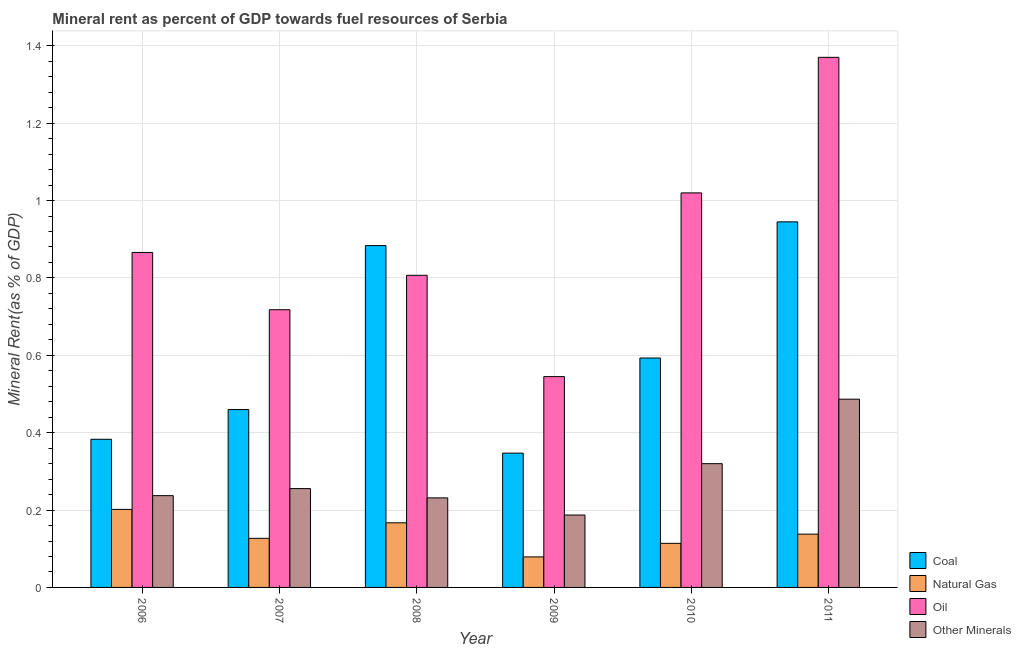How many different coloured bars are there?
Provide a short and direct response. 4. How many bars are there on the 2nd tick from the left?
Your answer should be very brief. 4. How many bars are there on the 1st tick from the right?
Ensure brevity in your answer.  4. What is the coal rent in 2008?
Provide a succinct answer. 0.88. Across all years, what is the maximum coal rent?
Keep it short and to the point. 0.94. Across all years, what is the minimum oil rent?
Provide a short and direct response. 0.54. In which year was the oil rent maximum?
Provide a short and direct response. 2011. In which year was the  rent of other minerals minimum?
Offer a very short reply. 2009. What is the total  rent of other minerals in the graph?
Make the answer very short. 1.72. What is the difference between the  rent of other minerals in 2006 and that in 2007?
Offer a terse response. -0.02. What is the difference between the  rent of other minerals in 2008 and the coal rent in 2006?
Offer a very short reply. -0.01. What is the average  rent of other minerals per year?
Provide a succinct answer. 0.29. What is the ratio of the coal rent in 2010 to that in 2011?
Keep it short and to the point. 0.63. What is the difference between the highest and the second highest natural gas rent?
Make the answer very short. 0.03. What is the difference between the highest and the lowest coal rent?
Make the answer very short. 0.6. In how many years, is the coal rent greater than the average coal rent taken over all years?
Give a very brief answer. 2. Is it the case that in every year, the sum of the coal rent and oil rent is greater than the sum of  rent of other minerals and natural gas rent?
Your answer should be very brief. No. What does the 1st bar from the left in 2006 represents?
Ensure brevity in your answer.  Coal. What does the 1st bar from the right in 2009 represents?
Keep it short and to the point. Other Minerals. How many bars are there?
Your answer should be compact. 24. Are all the bars in the graph horizontal?
Provide a succinct answer. No. Are the values on the major ticks of Y-axis written in scientific E-notation?
Your answer should be compact. No. How many legend labels are there?
Make the answer very short. 4. What is the title of the graph?
Make the answer very short. Mineral rent as percent of GDP towards fuel resources of Serbia. Does "Environmental sustainability" appear as one of the legend labels in the graph?
Offer a very short reply. No. What is the label or title of the Y-axis?
Keep it short and to the point. Mineral Rent(as % of GDP). What is the Mineral Rent(as % of GDP) of Coal in 2006?
Keep it short and to the point. 0.38. What is the Mineral Rent(as % of GDP) in Natural Gas in 2006?
Provide a succinct answer. 0.2. What is the Mineral Rent(as % of GDP) of Oil in 2006?
Keep it short and to the point. 0.87. What is the Mineral Rent(as % of GDP) in Other Minerals in 2006?
Your answer should be compact. 0.24. What is the Mineral Rent(as % of GDP) in Coal in 2007?
Provide a short and direct response. 0.46. What is the Mineral Rent(as % of GDP) of Natural Gas in 2007?
Offer a terse response. 0.13. What is the Mineral Rent(as % of GDP) of Oil in 2007?
Make the answer very short. 0.72. What is the Mineral Rent(as % of GDP) in Other Minerals in 2007?
Your answer should be very brief. 0.26. What is the Mineral Rent(as % of GDP) of Coal in 2008?
Provide a succinct answer. 0.88. What is the Mineral Rent(as % of GDP) of Natural Gas in 2008?
Give a very brief answer. 0.17. What is the Mineral Rent(as % of GDP) in Oil in 2008?
Your response must be concise. 0.81. What is the Mineral Rent(as % of GDP) of Other Minerals in 2008?
Provide a short and direct response. 0.23. What is the Mineral Rent(as % of GDP) of Coal in 2009?
Make the answer very short. 0.35. What is the Mineral Rent(as % of GDP) in Natural Gas in 2009?
Give a very brief answer. 0.08. What is the Mineral Rent(as % of GDP) of Oil in 2009?
Provide a succinct answer. 0.54. What is the Mineral Rent(as % of GDP) in Other Minerals in 2009?
Ensure brevity in your answer.  0.19. What is the Mineral Rent(as % of GDP) in Coal in 2010?
Your response must be concise. 0.59. What is the Mineral Rent(as % of GDP) of Natural Gas in 2010?
Ensure brevity in your answer.  0.11. What is the Mineral Rent(as % of GDP) of Oil in 2010?
Give a very brief answer. 1.02. What is the Mineral Rent(as % of GDP) in Other Minerals in 2010?
Give a very brief answer. 0.32. What is the Mineral Rent(as % of GDP) in Coal in 2011?
Provide a short and direct response. 0.94. What is the Mineral Rent(as % of GDP) of Natural Gas in 2011?
Give a very brief answer. 0.14. What is the Mineral Rent(as % of GDP) in Oil in 2011?
Your response must be concise. 1.37. What is the Mineral Rent(as % of GDP) of Other Minerals in 2011?
Your answer should be very brief. 0.49. Across all years, what is the maximum Mineral Rent(as % of GDP) in Coal?
Make the answer very short. 0.94. Across all years, what is the maximum Mineral Rent(as % of GDP) in Natural Gas?
Keep it short and to the point. 0.2. Across all years, what is the maximum Mineral Rent(as % of GDP) of Oil?
Your response must be concise. 1.37. Across all years, what is the maximum Mineral Rent(as % of GDP) of Other Minerals?
Provide a succinct answer. 0.49. Across all years, what is the minimum Mineral Rent(as % of GDP) in Coal?
Provide a short and direct response. 0.35. Across all years, what is the minimum Mineral Rent(as % of GDP) of Natural Gas?
Give a very brief answer. 0.08. Across all years, what is the minimum Mineral Rent(as % of GDP) in Oil?
Your answer should be compact. 0.54. Across all years, what is the minimum Mineral Rent(as % of GDP) in Other Minerals?
Your answer should be very brief. 0.19. What is the total Mineral Rent(as % of GDP) in Coal in the graph?
Offer a terse response. 3.61. What is the total Mineral Rent(as % of GDP) in Natural Gas in the graph?
Your answer should be compact. 0.83. What is the total Mineral Rent(as % of GDP) of Oil in the graph?
Provide a short and direct response. 5.33. What is the total Mineral Rent(as % of GDP) in Other Minerals in the graph?
Keep it short and to the point. 1.72. What is the difference between the Mineral Rent(as % of GDP) in Coal in 2006 and that in 2007?
Your answer should be very brief. -0.08. What is the difference between the Mineral Rent(as % of GDP) of Natural Gas in 2006 and that in 2007?
Make the answer very short. 0.07. What is the difference between the Mineral Rent(as % of GDP) in Oil in 2006 and that in 2007?
Offer a terse response. 0.15. What is the difference between the Mineral Rent(as % of GDP) of Other Minerals in 2006 and that in 2007?
Provide a succinct answer. -0.02. What is the difference between the Mineral Rent(as % of GDP) in Coal in 2006 and that in 2008?
Offer a very short reply. -0.5. What is the difference between the Mineral Rent(as % of GDP) in Natural Gas in 2006 and that in 2008?
Provide a short and direct response. 0.03. What is the difference between the Mineral Rent(as % of GDP) in Oil in 2006 and that in 2008?
Keep it short and to the point. 0.06. What is the difference between the Mineral Rent(as % of GDP) in Other Minerals in 2006 and that in 2008?
Offer a very short reply. 0.01. What is the difference between the Mineral Rent(as % of GDP) in Coal in 2006 and that in 2009?
Make the answer very short. 0.04. What is the difference between the Mineral Rent(as % of GDP) in Natural Gas in 2006 and that in 2009?
Offer a very short reply. 0.12. What is the difference between the Mineral Rent(as % of GDP) in Oil in 2006 and that in 2009?
Give a very brief answer. 0.32. What is the difference between the Mineral Rent(as % of GDP) in Other Minerals in 2006 and that in 2009?
Provide a short and direct response. 0.05. What is the difference between the Mineral Rent(as % of GDP) of Coal in 2006 and that in 2010?
Give a very brief answer. -0.21. What is the difference between the Mineral Rent(as % of GDP) of Natural Gas in 2006 and that in 2010?
Provide a succinct answer. 0.09. What is the difference between the Mineral Rent(as % of GDP) in Oil in 2006 and that in 2010?
Keep it short and to the point. -0.15. What is the difference between the Mineral Rent(as % of GDP) in Other Minerals in 2006 and that in 2010?
Make the answer very short. -0.08. What is the difference between the Mineral Rent(as % of GDP) in Coal in 2006 and that in 2011?
Provide a succinct answer. -0.56. What is the difference between the Mineral Rent(as % of GDP) in Natural Gas in 2006 and that in 2011?
Give a very brief answer. 0.06. What is the difference between the Mineral Rent(as % of GDP) in Oil in 2006 and that in 2011?
Provide a succinct answer. -0.5. What is the difference between the Mineral Rent(as % of GDP) of Other Minerals in 2006 and that in 2011?
Give a very brief answer. -0.25. What is the difference between the Mineral Rent(as % of GDP) of Coal in 2007 and that in 2008?
Make the answer very short. -0.42. What is the difference between the Mineral Rent(as % of GDP) in Natural Gas in 2007 and that in 2008?
Your answer should be compact. -0.04. What is the difference between the Mineral Rent(as % of GDP) in Oil in 2007 and that in 2008?
Ensure brevity in your answer.  -0.09. What is the difference between the Mineral Rent(as % of GDP) of Other Minerals in 2007 and that in 2008?
Give a very brief answer. 0.02. What is the difference between the Mineral Rent(as % of GDP) of Coal in 2007 and that in 2009?
Your answer should be very brief. 0.11. What is the difference between the Mineral Rent(as % of GDP) in Natural Gas in 2007 and that in 2009?
Provide a succinct answer. 0.05. What is the difference between the Mineral Rent(as % of GDP) of Oil in 2007 and that in 2009?
Ensure brevity in your answer.  0.17. What is the difference between the Mineral Rent(as % of GDP) in Other Minerals in 2007 and that in 2009?
Your response must be concise. 0.07. What is the difference between the Mineral Rent(as % of GDP) in Coal in 2007 and that in 2010?
Ensure brevity in your answer.  -0.13. What is the difference between the Mineral Rent(as % of GDP) of Natural Gas in 2007 and that in 2010?
Provide a short and direct response. 0.01. What is the difference between the Mineral Rent(as % of GDP) in Oil in 2007 and that in 2010?
Provide a short and direct response. -0.3. What is the difference between the Mineral Rent(as % of GDP) in Other Minerals in 2007 and that in 2010?
Your response must be concise. -0.06. What is the difference between the Mineral Rent(as % of GDP) of Coal in 2007 and that in 2011?
Keep it short and to the point. -0.49. What is the difference between the Mineral Rent(as % of GDP) of Natural Gas in 2007 and that in 2011?
Your response must be concise. -0.01. What is the difference between the Mineral Rent(as % of GDP) of Oil in 2007 and that in 2011?
Give a very brief answer. -0.65. What is the difference between the Mineral Rent(as % of GDP) of Other Minerals in 2007 and that in 2011?
Your answer should be compact. -0.23. What is the difference between the Mineral Rent(as % of GDP) of Coal in 2008 and that in 2009?
Offer a very short reply. 0.54. What is the difference between the Mineral Rent(as % of GDP) of Natural Gas in 2008 and that in 2009?
Keep it short and to the point. 0.09. What is the difference between the Mineral Rent(as % of GDP) of Oil in 2008 and that in 2009?
Offer a very short reply. 0.26. What is the difference between the Mineral Rent(as % of GDP) in Other Minerals in 2008 and that in 2009?
Offer a terse response. 0.04. What is the difference between the Mineral Rent(as % of GDP) of Coal in 2008 and that in 2010?
Provide a short and direct response. 0.29. What is the difference between the Mineral Rent(as % of GDP) in Natural Gas in 2008 and that in 2010?
Offer a very short reply. 0.05. What is the difference between the Mineral Rent(as % of GDP) in Oil in 2008 and that in 2010?
Provide a short and direct response. -0.21. What is the difference between the Mineral Rent(as % of GDP) in Other Minerals in 2008 and that in 2010?
Provide a short and direct response. -0.09. What is the difference between the Mineral Rent(as % of GDP) in Coal in 2008 and that in 2011?
Keep it short and to the point. -0.06. What is the difference between the Mineral Rent(as % of GDP) of Natural Gas in 2008 and that in 2011?
Your answer should be very brief. 0.03. What is the difference between the Mineral Rent(as % of GDP) of Oil in 2008 and that in 2011?
Keep it short and to the point. -0.56. What is the difference between the Mineral Rent(as % of GDP) in Other Minerals in 2008 and that in 2011?
Your answer should be compact. -0.26. What is the difference between the Mineral Rent(as % of GDP) of Coal in 2009 and that in 2010?
Your response must be concise. -0.25. What is the difference between the Mineral Rent(as % of GDP) of Natural Gas in 2009 and that in 2010?
Your answer should be very brief. -0.04. What is the difference between the Mineral Rent(as % of GDP) in Oil in 2009 and that in 2010?
Offer a very short reply. -0.47. What is the difference between the Mineral Rent(as % of GDP) in Other Minerals in 2009 and that in 2010?
Offer a very short reply. -0.13. What is the difference between the Mineral Rent(as % of GDP) in Coal in 2009 and that in 2011?
Keep it short and to the point. -0.6. What is the difference between the Mineral Rent(as % of GDP) in Natural Gas in 2009 and that in 2011?
Ensure brevity in your answer.  -0.06. What is the difference between the Mineral Rent(as % of GDP) in Oil in 2009 and that in 2011?
Provide a succinct answer. -0.83. What is the difference between the Mineral Rent(as % of GDP) in Other Minerals in 2009 and that in 2011?
Make the answer very short. -0.3. What is the difference between the Mineral Rent(as % of GDP) of Coal in 2010 and that in 2011?
Offer a terse response. -0.35. What is the difference between the Mineral Rent(as % of GDP) in Natural Gas in 2010 and that in 2011?
Ensure brevity in your answer.  -0.02. What is the difference between the Mineral Rent(as % of GDP) of Oil in 2010 and that in 2011?
Provide a short and direct response. -0.35. What is the difference between the Mineral Rent(as % of GDP) of Other Minerals in 2010 and that in 2011?
Provide a short and direct response. -0.17. What is the difference between the Mineral Rent(as % of GDP) in Coal in 2006 and the Mineral Rent(as % of GDP) in Natural Gas in 2007?
Give a very brief answer. 0.26. What is the difference between the Mineral Rent(as % of GDP) in Coal in 2006 and the Mineral Rent(as % of GDP) in Oil in 2007?
Provide a short and direct response. -0.33. What is the difference between the Mineral Rent(as % of GDP) of Coal in 2006 and the Mineral Rent(as % of GDP) of Other Minerals in 2007?
Keep it short and to the point. 0.13. What is the difference between the Mineral Rent(as % of GDP) in Natural Gas in 2006 and the Mineral Rent(as % of GDP) in Oil in 2007?
Provide a short and direct response. -0.52. What is the difference between the Mineral Rent(as % of GDP) of Natural Gas in 2006 and the Mineral Rent(as % of GDP) of Other Minerals in 2007?
Provide a short and direct response. -0.05. What is the difference between the Mineral Rent(as % of GDP) of Oil in 2006 and the Mineral Rent(as % of GDP) of Other Minerals in 2007?
Offer a very short reply. 0.61. What is the difference between the Mineral Rent(as % of GDP) in Coal in 2006 and the Mineral Rent(as % of GDP) in Natural Gas in 2008?
Make the answer very short. 0.22. What is the difference between the Mineral Rent(as % of GDP) of Coal in 2006 and the Mineral Rent(as % of GDP) of Oil in 2008?
Your answer should be compact. -0.42. What is the difference between the Mineral Rent(as % of GDP) in Coal in 2006 and the Mineral Rent(as % of GDP) in Other Minerals in 2008?
Keep it short and to the point. 0.15. What is the difference between the Mineral Rent(as % of GDP) in Natural Gas in 2006 and the Mineral Rent(as % of GDP) in Oil in 2008?
Make the answer very short. -0.61. What is the difference between the Mineral Rent(as % of GDP) of Natural Gas in 2006 and the Mineral Rent(as % of GDP) of Other Minerals in 2008?
Your answer should be very brief. -0.03. What is the difference between the Mineral Rent(as % of GDP) of Oil in 2006 and the Mineral Rent(as % of GDP) of Other Minerals in 2008?
Your response must be concise. 0.63. What is the difference between the Mineral Rent(as % of GDP) in Coal in 2006 and the Mineral Rent(as % of GDP) in Natural Gas in 2009?
Offer a very short reply. 0.3. What is the difference between the Mineral Rent(as % of GDP) of Coal in 2006 and the Mineral Rent(as % of GDP) of Oil in 2009?
Offer a terse response. -0.16. What is the difference between the Mineral Rent(as % of GDP) of Coal in 2006 and the Mineral Rent(as % of GDP) of Other Minerals in 2009?
Your response must be concise. 0.2. What is the difference between the Mineral Rent(as % of GDP) of Natural Gas in 2006 and the Mineral Rent(as % of GDP) of Oil in 2009?
Give a very brief answer. -0.34. What is the difference between the Mineral Rent(as % of GDP) in Natural Gas in 2006 and the Mineral Rent(as % of GDP) in Other Minerals in 2009?
Offer a very short reply. 0.01. What is the difference between the Mineral Rent(as % of GDP) in Oil in 2006 and the Mineral Rent(as % of GDP) in Other Minerals in 2009?
Offer a very short reply. 0.68. What is the difference between the Mineral Rent(as % of GDP) in Coal in 2006 and the Mineral Rent(as % of GDP) in Natural Gas in 2010?
Offer a very short reply. 0.27. What is the difference between the Mineral Rent(as % of GDP) in Coal in 2006 and the Mineral Rent(as % of GDP) in Oil in 2010?
Provide a succinct answer. -0.64. What is the difference between the Mineral Rent(as % of GDP) of Coal in 2006 and the Mineral Rent(as % of GDP) of Other Minerals in 2010?
Your answer should be very brief. 0.06. What is the difference between the Mineral Rent(as % of GDP) of Natural Gas in 2006 and the Mineral Rent(as % of GDP) of Oil in 2010?
Your answer should be very brief. -0.82. What is the difference between the Mineral Rent(as % of GDP) of Natural Gas in 2006 and the Mineral Rent(as % of GDP) of Other Minerals in 2010?
Ensure brevity in your answer.  -0.12. What is the difference between the Mineral Rent(as % of GDP) in Oil in 2006 and the Mineral Rent(as % of GDP) in Other Minerals in 2010?
Your response must be concise. 0.55. What is the difference between the Mineral Rent(as % of GDP) in Coal in 2006 and the Mineral Rent(as % of GDP) in Natural Gas in 2011?
Your answer should be compact. 0.25. What is the difference between the Mineral Rent(as % of GDP) in Coal in 2006 and the Mineral Rent(as % of GDP) in Oil in 2011?
Provide a short and direct response. -0.99. What is the difference between the Mineral Rent(as % of GDP) in Coal in 2006 and the Mineral Rent(as % of GDP) in Other Minerals in 2011?
Give a very brief answer. -0.1. What is the difference between the Mineral Rent(as % of GDP) in Natural Gas in 2006 and the Mineral Rent(as % of GDP) in Oil in 2011?
Provide a short and direct response. -1.17. What is the difference between the Mineral Rent(as % of GDP) of Natural Gas in 2006 and the Mineral Rent(as % of GDP) of Other Minerals in 2011?
Keep it short and to the point. -0.28. What is the difference between the Mineral Rent(as % of GDP) in Oil in 2006 and the Mineral Rent(as % of GDP) in Other Minerals in 2011?
Offer a terse response. 0.38. What is the difference between the Mineral Rent(as % of GDP) in Coal in 2007 and the Mineral Rent(as % of GDP) in Natural Gas in 2008?
Your answer should be compact. 0.29. What is the difference between the Mineral Rent(as % of GDP) of Coal in 2007 and the Mineral Rent(as % of GDP) of Oil in 2008?
Your answer should be compact. -0.35. What is the difference between the Mineral Rent(as % of GDP) of Coal in 2007 and the Mineral Rent(as % of GDP) of Other Minerals in 2008?
Offer a very short reply. 0.23. What is the difference between the Mineral Rent(as % of GDP) of Natural Gas in 2007 and the Mineral Rent(as % of GDP) of Oil in 2008?
Give a very brief answer. -0.68. What is the difference between the Mineral Rent(as % of GDP) of Natural Gas in 2007 and the Mineral Rent(as % of GDP) of Other Minerals in 2008?
Give a very brief answer. -0.1. What is the difference between the Mineral Rent(as % of GDP) of Oil in 2007 and the Mineral Rent(as % of GDP) of Other Minerals in 2008?
Ensure brevity in your answer.  0.49. What is the difference between the Mineral Rent(as % of GDP) of Coal in 2007 and the Mineral Rent(as % of GDP) of Natural Gas in 2009?
Give a very brief answer. 0.38. What is the difference between the Mineral Rent(as % of GDP) of Coal in 2007 and the Mineral Rent(as % of GDP) of Oil in 2009?
Your response must be concise. -0.09. What is the difference between the Mineral Rent(as % of GDP) in Coal in 2007 and the Mineral Rent(as % of GDP) in Other Minerals in 2009?
Give a very brief answer. 0.27. What is the difference between the Mineral Rent(as % of GDP) in Natural Gas in 2007 and the Mineral Rent(as % of GDP) in Oil in 2009?
Offer a very short reply. -0.42. What is the difference between the Mineral Rent(as % of GDP) of Natural Gas in 2007 and the Mineral Rent(as % of GDP) of Other Minerals in 2009?
Give a very brief answer. -0.06. What is the difference between the Mineral Rent(as % of GDP) in Oil in 2007 and the Mineral Rent(as % of GDP) in Other Minerals in 2009?
Offer a very short reply. 0.53. What is the difference between the Mineral Rent(as % of GDP) in Coal in 2007 and the Mineral Rent(as % of GDP) in Natural Gas in 2010?
Your response must be concise. 0.35. What is the difference between the Mineral Rent(as % of GDP) in Coal in 2007 and the Mineral Rent(as % of GDP) in Oil in 2010?
Give a very brief answer. -0.56. What is the difference between the Mineral Rent(as % of GDP) in Coal in 2007 and the Mineral Rent(as % of GDP) in Other Minerals in 2010?
Make the answer very short. 0.14. What is the difference between the Mineral Rent(as % of GDP) of Natural Gas in 2007 and the Mineral Rent(as % of GDP) of Oil in 2010?
Ensure brevity in your answer.  -0.89. What is the difference between the Mineral Rent(as % of GDP) of Natural Gas in 2007 and the Mineral Rent(as % of GDP) of Other Minerals in 2010?
Provide a succinct answer. -0.19. What is the difference between the Mineral Rent(as % of GDP) in Oil in 2007 and the Mineral Rent(as % of GDP) in Other Minerals in 2010?
Make the answer very short. 0.4. What is the difference between the Mineral Rent(as % of GDP) in Coal in 2007 and the Mineral Rent(as % of GDP) in Natural Gas in 2011?
Give a very brief answer. 0.32. What is the difference between the Mineral Rent(as % of GDP) of Coal in 2007 and the Mineral Rent(as % of GDP) of Oil in 2011?
Provide a succinct answer. -0.91. What is the difference between the Mineral Rent(as % of GDP) in Coal in 2007 and the Mineral Rent(as % of GDP) in Other Minerals in 2011?
Give a very brief answer. -0.03. What is the difference between the Mineral Rent(as % of GDP) in Natural Gas in 2007 and the Mineral Rent(as % of GDP) in Oil in 2011?
Ensure brevity in your answer.  -1.24. What is the difference between the Mineral Rent(as % of GDP) of Natural Gas in 2007 and the Mineral Rent(as % of GDP) of Other Minerals in 2011?
Offer a very short reply. -0.36. What is the difference between the Mineral Rent(as % of GDP) in Oil in 2007 and the Mineral Rent(as % of GDP) in Other Minerals in 2011?
Provide a short and direct response. 0.23. What is the difference between the Mineral Rent(as % of GDP) in Coal in 2008 and the Mineral Rent(as % of GDP) in Natural Gas in 2009?
Keep it short and to the point. 0.8. What is the difference between the Mineral Rent(as % of GDP) of Coal in 2008 and the Mineral Rent(as % of GDP) of Oil in 2009?
Ensure brevity in your answer.  0.34. What is the difference between the Mineral Rent(as % of GDP) in Coal in 2008 and the Mineral Rent(as % of GDP) in Other Minerals in 2009?
Provide a succinct answer. 0.7. What is the difference between the Mineral Rent(as % of GDP) of Natural Gas in 2008 and the Mineral Rent(as % of GDP) of Oil in 2009?
Your response must be concise. -0.38. What is the difference between the Mineral Rent(as % of GDP) of Natural Gas in 2008 and the Mineral Rent(as % of GDP) of Other Minerals in 2009?
Offer a very short reply. -0.02. What is the difference between the Mineral Rent(as % of GDP) of Oil in 2008 and the Mineral Rent(as % of GDP) of Other Minerals in 2009?
Offer a very short reply. 0.62. What is the difference between the Mineral Rent(as % of GDP) in Coal in 2008 and the Mineral Rent(as % of GDP) in Natural Gas in 2010?
Make the answer very short. 0.77. What is the difference between the Mineral Rent(as % of GDP) in Coal in 2008 and the Mineral Rent(as % of GDP) in Oil in 2010?
Give a very brief answer. -0.14. What is the difference between the Mineral Rent(as % of GDP) in Coal in 2008 and the Mineral Rent(as % of GDP) in Other Minerals in 2010?
Ensure brevity in your answer.  0.56. What is the difference between the Mineral Rent(as % of GDP) of Natural Gas in 2008 and the Mineral Rent(as % of GDP) of Oil in 2010?
Give a very brief answer. -0.85. What is the difference between the Mineral Rent(as % of GDP) in Natural Gas in 2008 and the Mineral Rent(as % of GDP) in Other Minerals in 2010?
Offer a terse response. -0.15. What is the difference between the Mineral Rent(as % of GDP) in Oil in 2008 and the Mineral Rent(as % of GDP) in Other Minerals in 2010?
Make the answer very short. 0.49. What is the difference between the Mineral Rent(as % of GDP) of Coal in 2008 and the Mineral Rent(as % of GDP) of Natural Gas in 2011?
Your response must be concise. 0.75. What is the difference between the Mineral Rent(as % of GDP) in Coal in 2008 and the Mineral Rent(as % of GDP) in Oil in 2011?
Your response must be concise. -0.49. What is the difference between the Mineral Rent(as % of GDP) of Coal in 2008 and the Mineral Rent(as % of GDP) of Other Minerals in 2011?
Provide a succinct answer. 0.4. What is the difference between the Mineral Rent(as % of GDP) in Natural Gas in 2008 and the Mineral Rent(as % of GDP) in Oil in 2011?
Your answer should be very brief. -1.2. What is the difference between the Mineral Rent(as % of GDP) in Natural Gas in 2008 and the Mineral Rent(as % of GDP) in Other Minerals in 2011?
Offer a very short reply. -0.32. What is the difference between the Mineral Rent(as % of GDP) of Oil in 2008 and the Mineral Rent(as % of GDP) of Other Minerals in 2011?
Provide a succinct answer. 0.32. What is the difference between the Mineral Rent(as % of GDP) in Coal in 2009 and the Mineral Rent(as % of GDP) in Natural Gas in 2010?
Your answer should be very brief. 0.23. What is the difference between the Mineral Rent(as % of GDP) in Coal in 2009 and the Mineral Rent(as % of GDP) in Oil in 2010?
Your answer should be very brief. -0.67. What is the difference between the Mineral Rent(as % of GDP) in Coal in 2009 and the Mineral Rent(as % of GDP) in Other Minerals in 2010?
Make the answer very short. 0.03. What is the difference between the Mineral Rent(as % of GDP) of Natural Gas in 2009 and the Mineral Rent(as % of GDP) of Oil in 2010?
Keep it short and to the point. -0.94. What is the difference between the Mineral Rent(as % of GDP) in Natural Gas in 2009 and the Mineral Rent(as % of GDP) in Other Minerals in 2010?
Your answer should be very brief. -0.24. What is the difference between the Mineral Rent(as % of GDP) of Oil in 2009 and the Mineral Rent(as % of GDP) of Other Minerals in 2010?
Make the answer very short. 0.23. What is the difference between the Mineral Rent(as % of GDP) of Coal in 2009 and the Mineral Rent(as % of GDP) of Natural Gas in 2011?
Provide a succinct answer. 0.21. What is the difference between the Mineral Rent(as % of GDP) in Coal in 2009 and the Mineral Rent(as % of GDP) in Oil in 2011?
Provide a short and direct response. -1.02. What is the difference between the Mineral Rent(as % of GDP) of Coal in 2009 and the Mineral Rent(as % of GDP) of Other Minerals in 2011?
Give a very brief answer. -0.14. What is the difference between the Mineral Rent(as % of GDP) in Natural Gas in 2009 and the Mineral Rent(as % of GDP) in Oil in 2011?
Your response must be concise. -1.29. What is the difference between the Mineral Rent(as % of GDP) of Natural Gas in 2009 and the Mineral Rent(as % of GDP) of Other Minerals in 2011?
Provide a short and direct response. -0.41. What is the difference between the Mineral Rent(as % of GDP) in Oil in 2009 and the Mineral Rent(as % of GDP) in Other Minerals in 2011?
Keep it short and to the point. 0.06. What is the difference between the Mineral Rent(as % of GDP) in Coal in 2010 and the Mineral Rent(as % of GDP) in Natural Gas in 2011?
Give a very brief answer. 0.46. What is the difference between the Mineral Rent(as % of GDP) in Coal in 2010 and the Mineral Rent(as % of GDP) in Oil in 2011?
Offer a very short reply. -0.78. What is the difference between the Mineral Rent(as % of GDP) in Coal in 2010 and the Mineral Rent(as % of GDP) in Other Minerals in 2011?
Offer a very short reply. 0.11. What is the difference between the Mineral Rent(as % of GDP) in Natural Gas in 2010 and the Mineral Rent(as % of GDP) in Oil in 2011?
Provide a succinct answer. -1.26. What is the difference between the Mineral Rent(as % of GDP) of Natural Gas in 2010 and the Mineral Rent(as % of GDP) of Other Minerals in 2011?
Keep it short and to the point. -0.37. What is the difference between the Mineral Rent(as % of GDP) in Oil in 2010 and the Mineral Rent(as % of GDP) in Other Minerals in 2011?
Offer a terse response. 0.53. What is the average Mineral Rent(as % of GDP) of Coal per year?
Ensure brevity in your answer.  0.6. What is the average Mineral Rent(as % of GDP) in Natural Gas per year?
Ensure brevity in your answer.  0.14. What is the average Mineral Rent(as % of GDP) in Oil per year?
Your answer should be very brief. 0.89. What is the average Mineral Rent(as % of GDP) in Other Minerals per year?
Offer a very short reply. 0.29. In the year 2006, what is the difference between the Mineral Rent(as % of GDP) in Coal and Mineral Rent(as % of GDP) in Natural Gas?
Your answer should be compact. 0.18. In the year 2006, what is the difference between the Mineral Rent(as % of GDP) of Coal and Mineral Rent(as % of GDP) of Oil?
Provide a succinct answer. -0.48. In the year 2006, what is the difference between the Mineral Rent(as % of GDP) of Coal and Mineral Rent(as % of GDP) of Other Minerals?
Your response must be concise. 0.15. In the year 2006, what is the difference between the Mineral Rent(as % of GDP) of Natural Gas and Mineral Rent(as % of GDP) of Oil?
Give a very brief answer. -0.66. In the year 2006, what is the difference between the Mineral Rent(as % of GDP) in Natural Gas and Mineral Rent(as % of GDP) in Other Minerals?
Your answer should be compact. -0.04. In the year 2006, what is the difference between the Mineral Rent(as % of GDP) in Oil and Mineral Rent(as % of GDP) in Other Minerals?
Ensure brevity in your answer.  0.63. In the year 2007, what is the difference between the Mineral Rent(as % of GDP) of Coal and Mineral Rent(as % of GDP) of Natural Gas?
Your answer should be very brief. 0.33. In the year 2007, what is the difference between the Mineral Rent(as % of GDP) of Coal and Mineral Rent(as % of GDP) of Oil?
Your response must be concise. -0.26. In the year 2007, what is the difference between the Mineral Rent(as % of GDP) in Coal and Mineral Rent(as % of GDP) in Other Minerals?
Make the answer very short. 0.2. In the year 2007, what is the difference between the Mineral Rent(as % of GDP) of Natural Gas and Mineral Rent(as % of GDP) of Oil?
Make the answer very short. -0.59. In the year 2007, what is the difference between the Mineral Rent(as % of GDP) of Natural Gas and Mineral Rent(as % of GDP) of Other Minerals?
Your response must be concise. -0.13. In the year 2007, what is the difference between the Mineral Rent(as % of GDP) in Oil and Mineral Rent(as % of GDP) in Other Minerals?
Your answer should be very brief. 0.46. In the year 2008, what is the difference between the Mineral Rent(as % of GDP) in Coal and Mineral Rent(as % of GDP) in Natural Gas?
Provide a succinct answer. 0.72. In the year 2008, what is the difference between the Mineral Rent(as % of GDP) of Coal and Mineral Rent(as % of GDP) of Oil?
Your response must be concise. 0.08. In the year 2008, what is the difference between the Mineral Rent(as % of GDP) in Coal and Mineral Rent(as % of GDP) in Other Minerals?
Offer a terse response. 0.65. In the year 2008, what is the difference between the Mineral Rent(as % of GDP) of Natural Gas and Mineral Rent(as % of GDP) of Oil?
Make the answer very short. -0.64. In the year 2008, what is the difference between the Mineral Rent(as % of GDP) of Natural Gas and Mineral Rent(as % of GDP) of Other Minerals?
Keep it short and to the point. -0.06. In the year 2008, what is the difference between the Mineral Rent(as % of GDP) of Oil and Mineral Rent(as % of GDP) of Other Minerals?
Your answer should be compact. 0.58. In the year 2009, what is the difference between the Mineral Rent(as % of GDP) of Coal and Mineral Rent(as % of GDP) of Natural Gas?
Ensure brevity in your answer.  0.27. In the year 2009, what is the difference between the Mineral Rent(as % of GDP) of Coal and Mineral Rent(as % of GDP) of Oil?
Keep it short and to the point. -0.2. In the year 2009, what is the difference between the Mineral Rent(as % of GDP) of Coal and Mineral Rent(as % of GDP) of Other Minerals?
Offer a very short reply. 0.16. In the year 2009, what is the difference between the Mineral Rent(as % of GDP) of Natural Gas and Mineral Rent(as % of GDP) of Oil?
Offer a very short reply. -0.47. In the year 2009, what is the difference between the Mineral Rent(as % of GDP) in Natural Gas and Mineral Rent(as % of GDP) in Other Minerals?
Provide a short and direct response. -0.11. In the year 2009, what is the difference between the Mineral Rent(as % of GDP) in Oil and Mineral Rent(as % of GDP) in Other Minerals?
Your answer should be very brief. 0.36. In the year 2010, what is the difference between the Mineral Rent(as % of GDP) of Coal and Mineral Rent(as % of GDP) of Natural Gas?
Your answer should be compact. 0.48. In the year 2010, what is the difference between the Mineral Rent(as % of GDP) of Coal and Mineral Rent(as % of GDP) of Oil?
Provide a succinct answer. -0.43. In the year 2010, what is the difference between the Mineral Rent(as % of GDP) of Coal and Mineral Rent(as % of GDP) of Other Minerals?
Provide a succinct answer. 0.27. In the year 2010, what is the difference between the Mineral Rent(as % of GDP) in Natural Gas and Mineral Rent(as % of GDP) in Oil?
Offer a terse response. -0.91. In the year 2010, what is the difference between the Mineral Rent(as % of GDP) of Natural Gas and Mineral Rent(as % of GDP) of Other Minerals?
Ensure brevity in your answer.  -0.21. In the year 2010, what is the difference between the Mineral Rent(as % of GDP) in Oil and Mineral Rent(as % of GDP) in Other Minerals?
Ensure brevity in your answer.  0.7. In the year 2011, what is the difference between the Mineral Rent(as % of GDP) in Coal and Mineral Rent(as % of GDP) in Natural Gas?
Your answer should be very brief. 0.81. In the year 2011, what is the difference between the Mineral Rent(as % of GDP) in Coal and Mineral Rent(as % of GDP) in Oil?
Your response must be concise. -0.43. In the year 2011, what is the difference between the Mineral Rent(as % of GDP) in Coal and Mineral Rent(as % of GDP) in Other Minerals?
Your answer should be compact. 0.46. In the year 2011, what is the difference between the Mineral Rent(as % of GDP) of Natural Gas and Mineral Rent(as % of GDP) of Oil?
Provide a succinct answer. -1.23. In the year 2011, what is the difference between the Mineral Rent(as % of GDP) in Natural Gas and Mineral Rent(as % of GDP) in Other Minerals?
Offer a terse response. -0.35. In the year 2011, what is the difference between the Mineral Rent(as % of GDP) of Oil and Mineral Rent(as % of GDP) of Other Minerals?
Provide a short and direct response. 0.88. What is the ratio of the Mineral Rent(as % of GDP) in Coal in 2006 to that in 2007?
Provide a short and direct response. 0.83. What is the ratio of the Mineral Rent(as % of GDP) in Natural Gas in 2006 to that in 2007?
Provide a succinct answer. 1.59. What is the ratio of the Mineral Rent(as % of GDP) of Oil in 2006 to that in 2007?
Offer a terse response. 1.21. What is the ratio of the Mineral Rent(as % of GDP) in Coal in 2006 to that in 2008?
Provide a short and direct response. 0.43. What is the ratio of the Mineral Rent(as % of GDP) of Natural Gas in 2006 to that in 2008?
Give a very brief answer. 1.21. What is the ratio of the Mineral Rent(as % of GDP) of Oil in 2006 to that in 2008?
Give a very brief answer. 1.07. What is the ratio of the Mineral Rent(as % of GDP) of Other Minerals in 2006 to that in 2008?
Make the answer very short. 1.02. What is the ratio of the Mineral Rent(as % of GDP) of Coal in 2006 to that in 2009?
Offer a terse response. 1.1. What is the ratio of the Mineral Rent(as % of GDP) in Natural Gas in 2006 to that in 2009?
Provide a short and direct response. 2.56. What is the ratio of the Mineral Rent(as % of GDP) in Oil in 2006 to that in 2009?
Make the answer very short. 1.59. What is the ratio of the Mineral Rent(as % of GDP) of Other Minerals in 2006 to that in 2009?
Keep it short and to the point. 1.27. What is the ratio of the Mineral Rent(as % of GDP) in Coal in 2006 to that in 2010?
Offer a very short reply. 0.65. What is the ratio of the Mineral Rent(as % of GDP) of Natural Gas in 2006 to that in 2010?
Your answer should be very brief. 1.77. What is the ratio of the Mineral Rent(as % of GDP) in Oil in 2006 to that in 2010?
Give a very brief answer. 0.85. What is the ratio of the Mineral Rent(as % of GDP) in Other Minerals in 2006 to that in 2010?
Keep it short and to the point. 0.74. What is the ratio of the Mineral Rent(as % of GDP) of Coal in 2006 to that in 2011?
Offer a terse response. 0.41. What is the ratio of the Mineral Rent(as % of GDP) of Natural Gas in 2006 to that in 2011?
Keep it short and to the point. 1.46. What is the ratio of the Mineral Rent(as % of GDP) in Oil in 2006 to that in 2011?
Offer a terse response. 0.63. What is the ratio of the Mineral Rent(as % of GDP) in Other Minerals in 2006 to that in 2011?
Provide a short and direct response. 0.49. What is the ratio of the Mineral Rent(as % of GDP) of Coal in 2007 to that in 2008?
Your answer should be very brief. 0.52. What is the ratio of the Mineral Rent(as % of GDP) in Natural Gas in 2007 to that in 2008?
Keep it short and to the point. 0.76. What is the ratio of the Mineral Rent(as % of GDP) of Oil in 2007 to that in 2008?
Your answer should be compact. 0.89. What is the ratio of the Mineral Rent(as % of GDP) of Other Minerals in 2007 to that in 2008?
Provide a succinct answer. 1.1. What is the ratio of the Mineral Rent(as % of GDP) in Coal in 2007 to that in 2009?
Keep it short and to the point. 1.32. What is the ratio of the Mineral Rent(as % of GDP) in Natural Gas in 2007 to that in 2009?
Offer a very short reply. 1.61. What is the ratio of the Mineral Rent(as % of GDP) in Oil in 2007 to that in 2009?
Provide a short and direct response. 1.32. What is the ratio of the Mineral Rent(as % of GDP) of Other Minerals in 2007 to that in 2009?
Your answer should be very brief. 1.37. What is the ratio of the Mineral Rent(as % of GDP) of Coal in 2007 to that in 2010?
Offer a terse response. 0.78. What is the ratio of the Mineral Rent(as % of GDP) in Natural Gas in 2007 to that in 2010?
Provide a short and direct response. 1.11. What is the ratio of the Mineral Rent(as % of GDP) of Oil in 2007 to that in 2010?
Offer a very short reply. 0.7. What is the ratio of the Mineral Rent(as % of GDP) in Other Minerals in 2007 to that in 2010?
Ensure brevity in your answer.  0.8. What is the ratio of the Mineral Rent(as % of GDP) of Coal in 2007 to that in 2011?
Provide a short and direct response. 0.49. What is the ratio of the Mineral Rent(as % of GDP) in Natural Gas in 2007 to that in 2011?
Your response must be concise. 0.92. What is the ratio of the Mineral Rent(as % of GDP) of Oil in 2007 to that in 2011?
Your answer should be very brief. 0.52. What is the ratio of the Mineral Rent(as % of GDP) in Other Minerals in 2007 to that in 2011?
Ensure brevity in your answer.  0.53. What is the ratio of the Mineral Rent(as % of GDP) of Coal in 2008 to that in 2009?
Offer a very short reply. 2.55. What is the ratio of the Mineral Rent(as % of GDP) in Natural Gas in 2008 to that in 2009?
Ensure brevity in your answer.  2.12. What is the ratio of the Mineral Rent(as % of GDP) of Oil in 2008 to that in 2009?
Provide a short and direct response. 1.48. What is the ratio of the Mineral Rent(as % of GDP) of Other Minerals in 2008 to that in 2009?
Your answer should be very brief. 1.24. What is the ratio of the Mineral Rent(as % of GDP) in Coal in 2008 to that in 2010?
Your answer should be compact. 1.49. What is the ratio of the Mineral Rent(as % of GDP) of Natural Gas in 2008 to that in 2010?
Provide a short and direct response. 1.47. What is the ratio of the Mineral Rent(as % of GDP) of Oil in 2008 to that in 2010?
Your response must be concise. 0.79. What is the ratio of the Mineral Rent(as % of GDP) in Other Minerals in 2008 to that in 2010?
Offer a terse response. 0.72. What is the ratio of the Mineral Rent(as % of GDP) of Coal in 2008 to that in 2011?
Offer a terse response. 0.94. What is the ratio of the Mineral Rent(as % of GDP) in Natural Gas in 2008 to that in 2011?
Offer a very short reply. 1.21. What is the ratio of the Mineral Rent(as % of GDP) in Oil in 2008 to that in 2011?
Your answer should be compact. 0.59. What is the ratio of the Mineral Rent(as % of GDP) of Other Minerals in 2008 to that in 2011?
Offer a very short reply. 0.48. What is the ratio of the Mineral Rent(as % of GDP) in Coal in 2009 to that in 2010?
Make the answer very short. 0.59. What is the ratio of the Mineral Rent(as % of GDP) of Natural Gas in 2009 to that in 2010?
Provide a succinct answer. 0.69. What is the ratio of the Mineral Rent(as % of GDP) of Oil in 2009 to that in 2010?
Your response must be concise. 0.53. What is the ratio of the Mineral Rent(as % of GDP) of Other Minerals in 2009 to that in 2010?
Ensure brevity in your answer.  0.58. What is the ratio of the Mineral Rent(as % of GDP) of Coal in 2009 to that in 2011?
Provide a succinct answer. 0.37. What is the ratio of the Mineral Rent(as % of GDP) in Natural Gas in 2009 to that in 2011?
Give a very brief answer. 0.57. What is the ratio of the Mineral Rent(as % of GDP) of Oil in 2009 to that in 2011?
Offer a very short reply. 0.4. What is the ratio of the Mineral Rent(as % of GDP) in Other Minerals in 2009 to that in 2011?
Your answer should be very brief. 0.38. What is the ratio of the Mineral Rent(as % of GDP) of Coal in 2010 to that in 2011?
Offer a terse response. 0.63. What is the ratio of the Mineral Rent(as % of GDP) of Natural Gas in 2010 to that in 2011?
Provide a succinct answer. 0.83. What is the ratio of the Mineral Rent(as % of GDP) in Oil in 2010 to that in 2011?
Make the answer very short. 0.74. What is the ratio of the Mineral Rent(as % of GDP) in Other Minerals in 2010 to that in 2011?
Your answer should be very brief. 0.66. What is the difference between the highest and the second highest Mineral Rent(as % of GDP) in Coal?
Provide a short and direct response. 0.06. What is the difference between the highest and the second highest Mineral Rent(as % of GDP) of Natural Gas?
Make the answer very short. 0.03. What is the difference between the highest and the second highest Mineral Rent(as % of GDP) in Oil?
Keep it short and to the point. 0.35. What is the difference between the highest and the lowest Mineral Rent(as % of GDP) of Coal?
Your answer should be compact. 0.6. What is the difference between the highest and the lowest Mineral Rent(as % of GDP) in Natural Gas?
Make the answer very short. 0.12. What is the difference between the highest and the lowest Mineral Rent(as % of GDP) of Oil?
Offer a very short reply. 0.83. What is the difference between the highest and the lowest Mineral Rent(as % of GDP) in Other Minerals?
Keep it short and to the point. 0.3. 